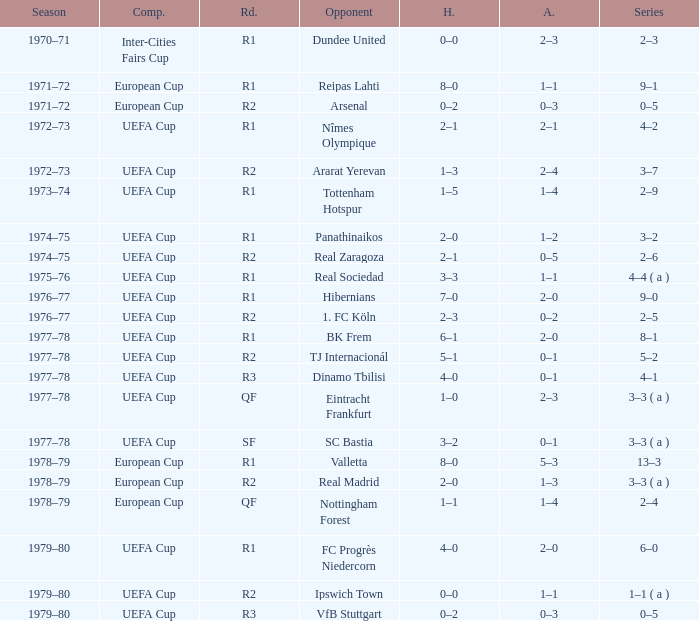Which Home has a Round of r1, and an Opponent of dundee united? 0–0. 